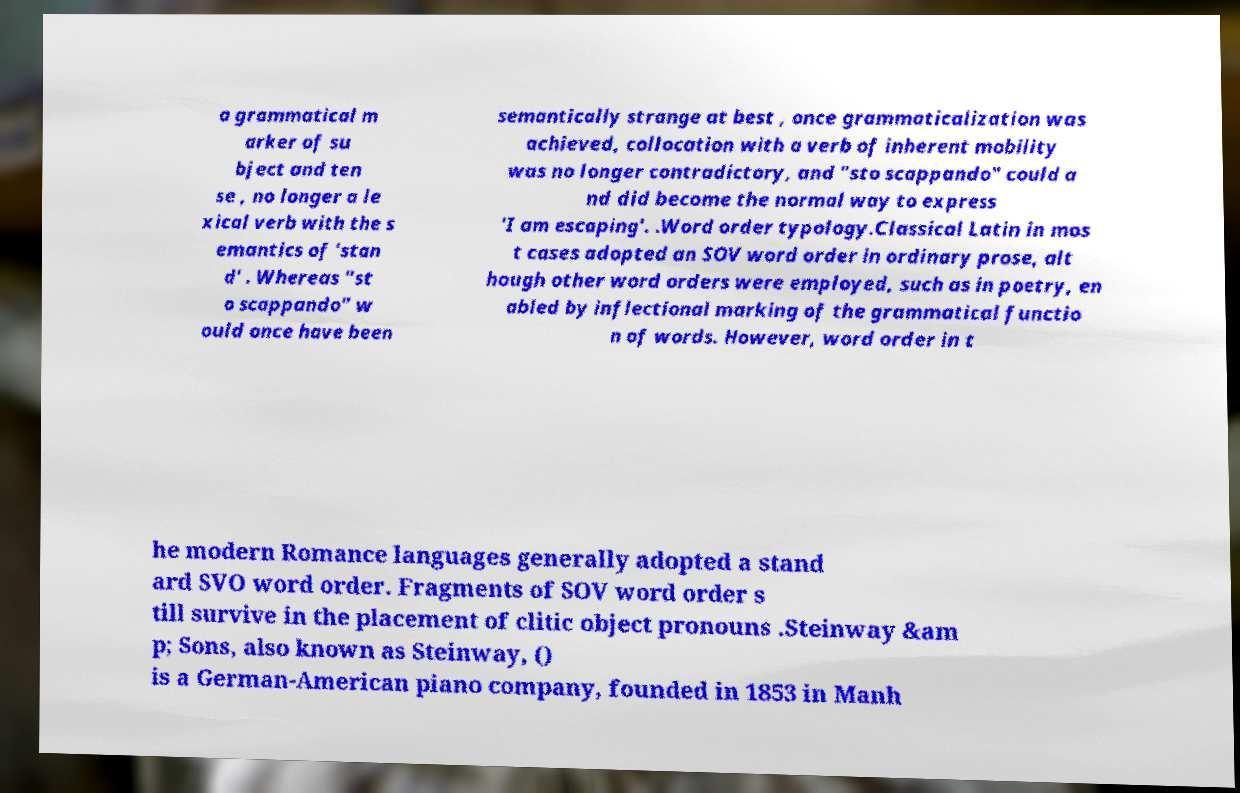Please read and relay the text visible in this image. What does it say? a grammatical m arker of su bject and ten se , no longer a le xical verb with the s emantics of 'stan d' . Whereas "st o scappando" w ould once have been semantically strange at best , once grammaticalization was achieved, collocation with a verb of inherent mobility was no longer contradictory, and "sto scappando" could a nd did become the normal way to express 'I am escaping'. .Word order typology.Classical Latin in mos t cases adopted an SOV word order in ordinary prose, alt hough other word orders were employed, such as in poetry, en abled by inflectional marking of the grammatical functio n of words. However, word order in t he modern Romance languages generally adopted a stand ard SVO word order. Fragments of SOV word order s till survive in the placement of clitic object pronouns .Steinway &am p; Sons, also known as Steinway, () is a German-American piano company, founded in 1853 in Manh 